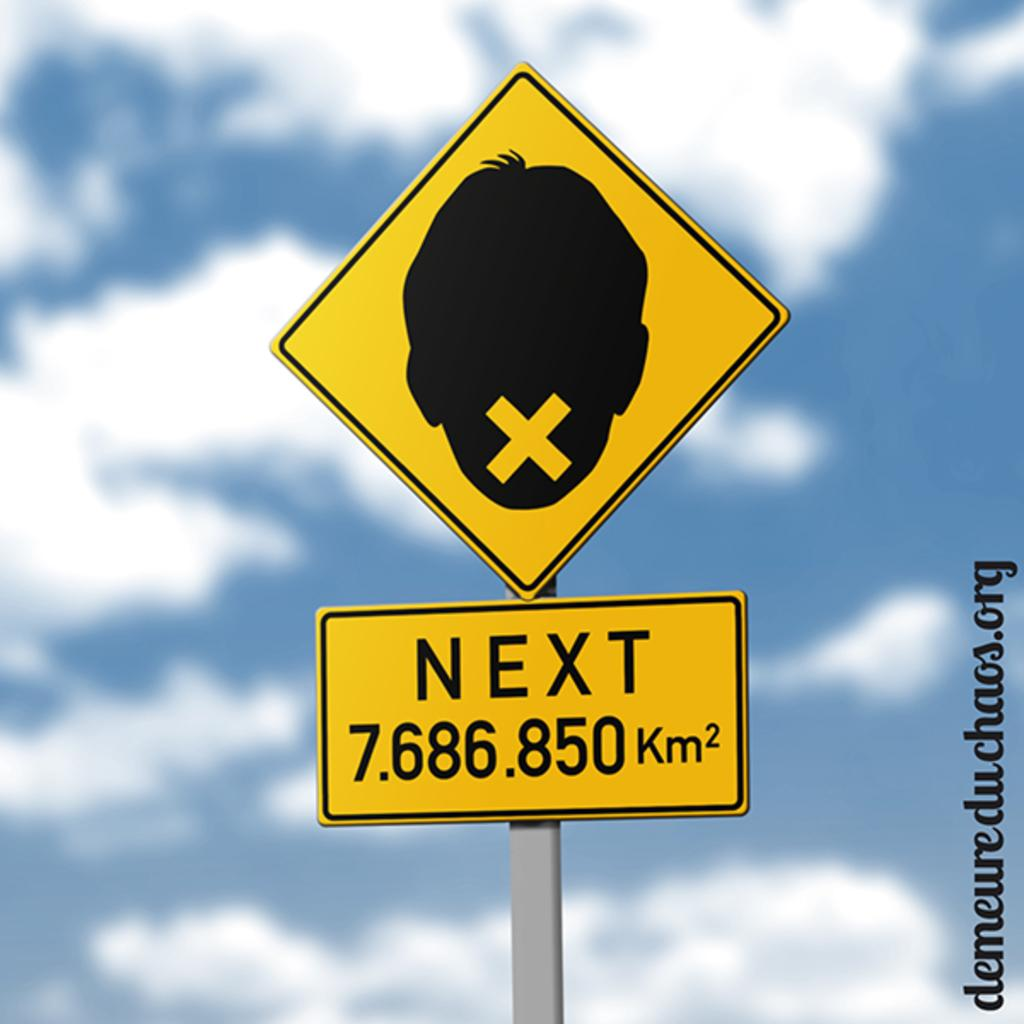<image>
Present a compact description of the photo's key features. road sign that have a boy head with a x on it and next sign 